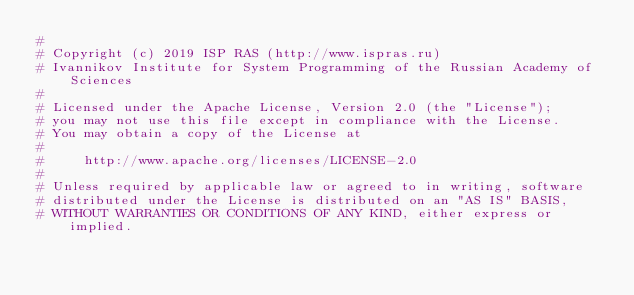<code> <loc_0><loc_0><loc_500><loc_500><_Python_>#
# Copyright (c) 2019 ISP RAS (http://www.ispras.ru)
# Ivannikov Institute for System Programming of the Russian Academy of Sciences
#
# Licensed under the Apache License, Version 2.0 (the "License");
# you may not use this file except in compliance with the License.
# You may obtain a copy of the License at
#
#     http://www.apache.org/licenses/LICENSE-2.0
#
# Unless required by applicable law or agreed to in writing, software
# distributed under the License is distributed on an "AS IS" BASIS,
# WITHOUT WARRANTIES OR CONDITIONS OF ANY KIND, either express or implied.</code> 